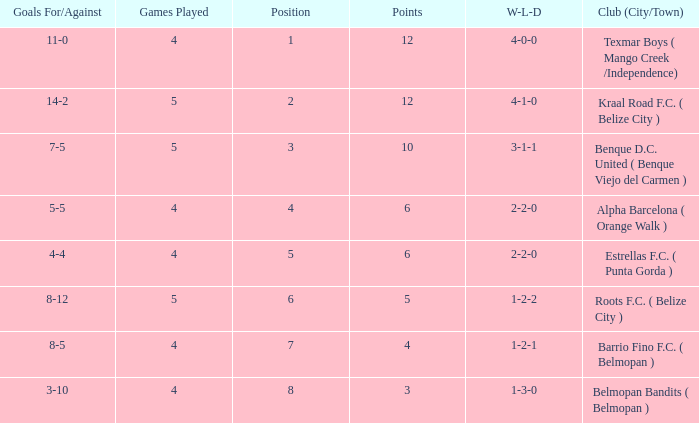What's the w-l-d with position being 1 4-0-0. 